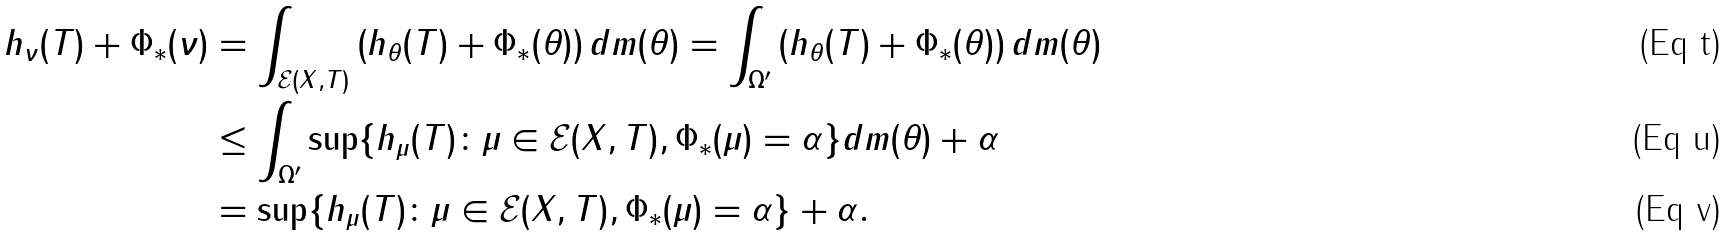Convert formula to latex. <formula><loc_0><loc_0><loc_500><loc_500>h _ { \nu } ( T ) + \Phi _ { * } ( \nu ) & = \int _ { \mathcal { E } ( X , T ) } \left ( h _ { \theta } ( T ) + \Phi _ { * } ( \theta ) \right ) d m ( \theta ) = \int _ { \Omega ^ { \prime } } \left ( h _ { \theta } ( T ) + \Phi _ { * } ( \theta ) \right ) d m ( \theta ) \\ & \leq \int _ { \Omega ^ { \prime } } \sup \{ h _ { \mu } ( T ) \colon \mu \in \mathcal { E } ( X , T ) , \Phi _ { * } ( \mu ) = \alpha \} d m ( \theta ) + \alpha \\ & = \sup \{ h _ { \mu } ( T ) \colon \mu \in \mathcal { E } ( X , T ) , \Phi _ { * } ( \mu ) = \alpha \} + \alpha .</formula> 